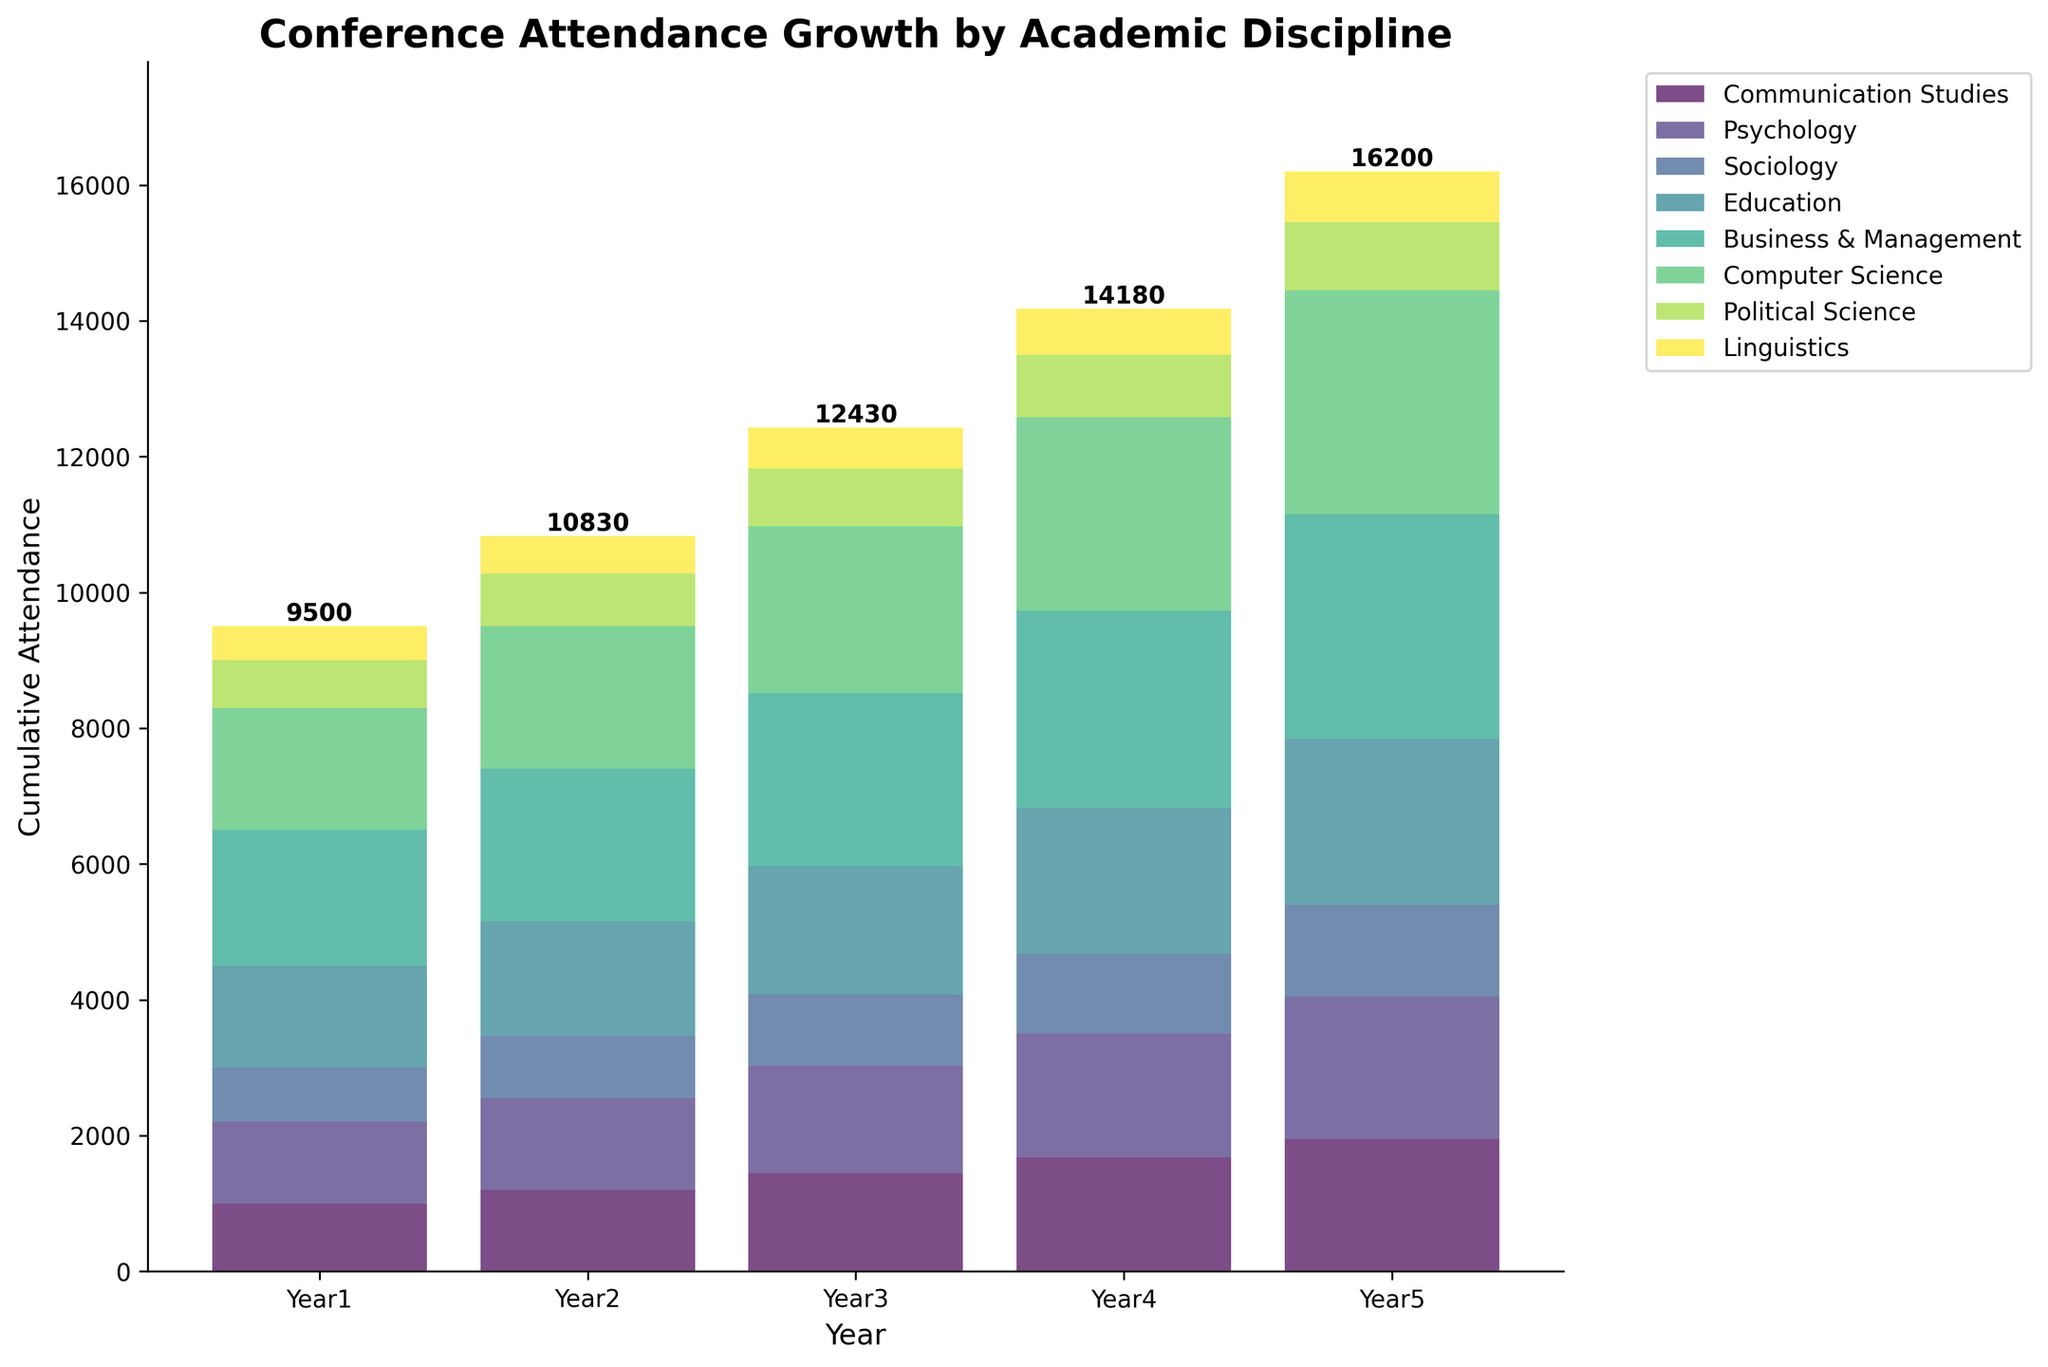What is the title of the chart? The title is usually displayed at the top of the chart in larger font size and often bolded.
Answer: Conference Attendance Growth by Academic Discipline What academic discipline had the highest conference attendance in Year 5? Find the academic discipline with the highest bar height in the Year 5 section.
Answer: Business & Management Which discipline saw a consistent increase in attendance every year? Look for a trend where the height of the bars for a discipline increases each subsequent year.
Answer: Communication Studies What was the total cumulative attendance in Year 3? Sum the heights of all bars in the Year 3 section. Each bar represents the attendance for a different discipline to get the cumulative total.
Answer: 11680 How much did Psychology's attendance increase from Year 1 to Year 5? Subtract the attendance in Year 1 from the attendance in Year 5 for the Psychology discipline.
Answer: 900 Which academic discipline saw the largest relative growth over the 5-year period? Calculate the percentage increase for each discipline from Year 1 to Year 5 and compare.
Answer: Computer Science In which year did Communication Studies have an attendance of 1450? Find the bar for Communication Studies and match it to the year where its height is 1450.
Answer: Year 3 Compare the attendance growth of Education and Sociology between Year 2 to Year 4. Which one grew more? Subtract the attendance values of Year 2 from Year 4 for both Education and Sociology, then compare the difference.
Answer: Education What two disciplines end with the same attendance number in Year 5? Look for bars with the same height in the Year 5 section and identify the corresponding disciplines.
Answer: Business & Management, Computer Science What's the average yearly attendance increase for Political Science over the 5 years? Calculate the total increase over the years and divide by the number of years (5).
Answer: 75 